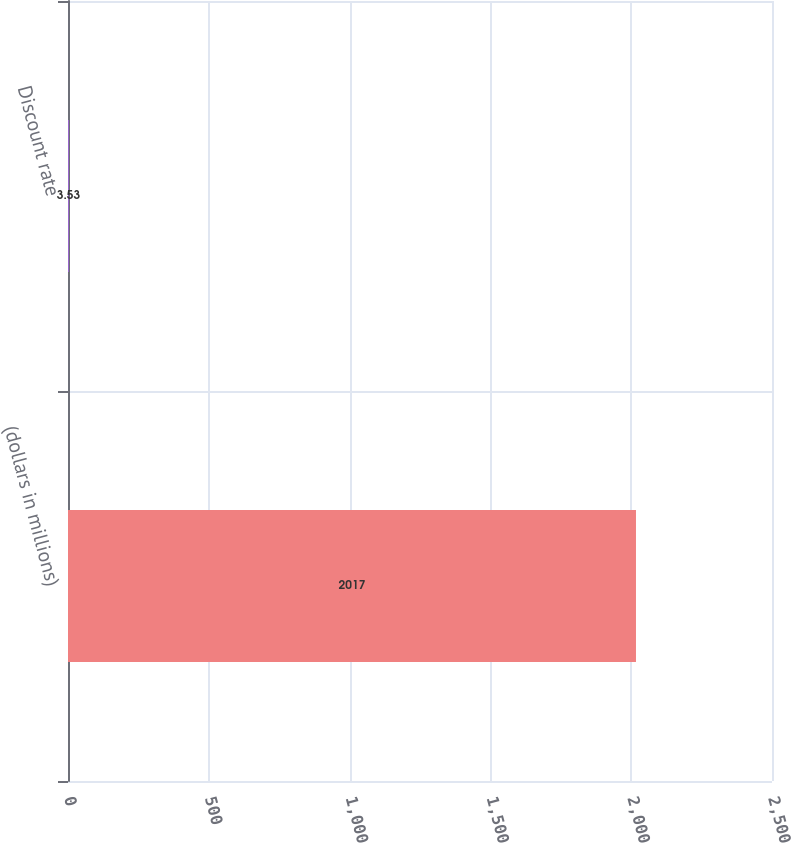Convert chart to OTSL. <chart><loc_0><loc_0><loc_500><loc_500><bar_chart><fcel>(dollars in millions)<fcel>Discount rate<nl><fcel>2017<fcel>3.53<nl></chart> 